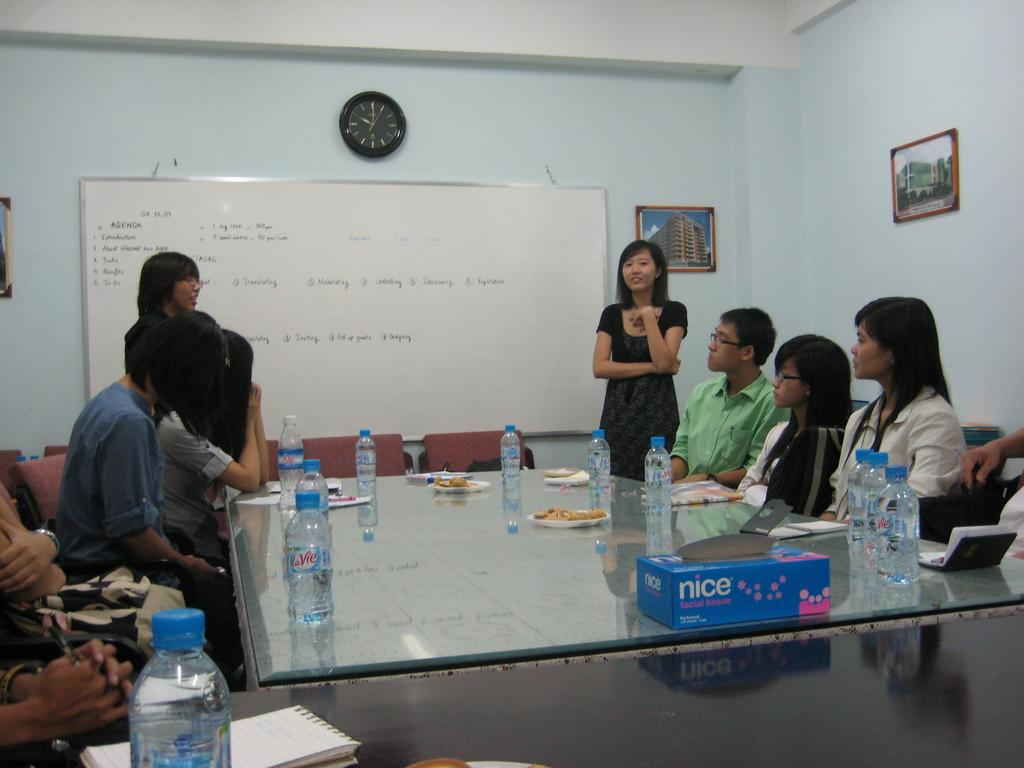<image>
Relay a brief, clear account of the picture shown. Several people sitting around a table with a box of nice tissue on it. 